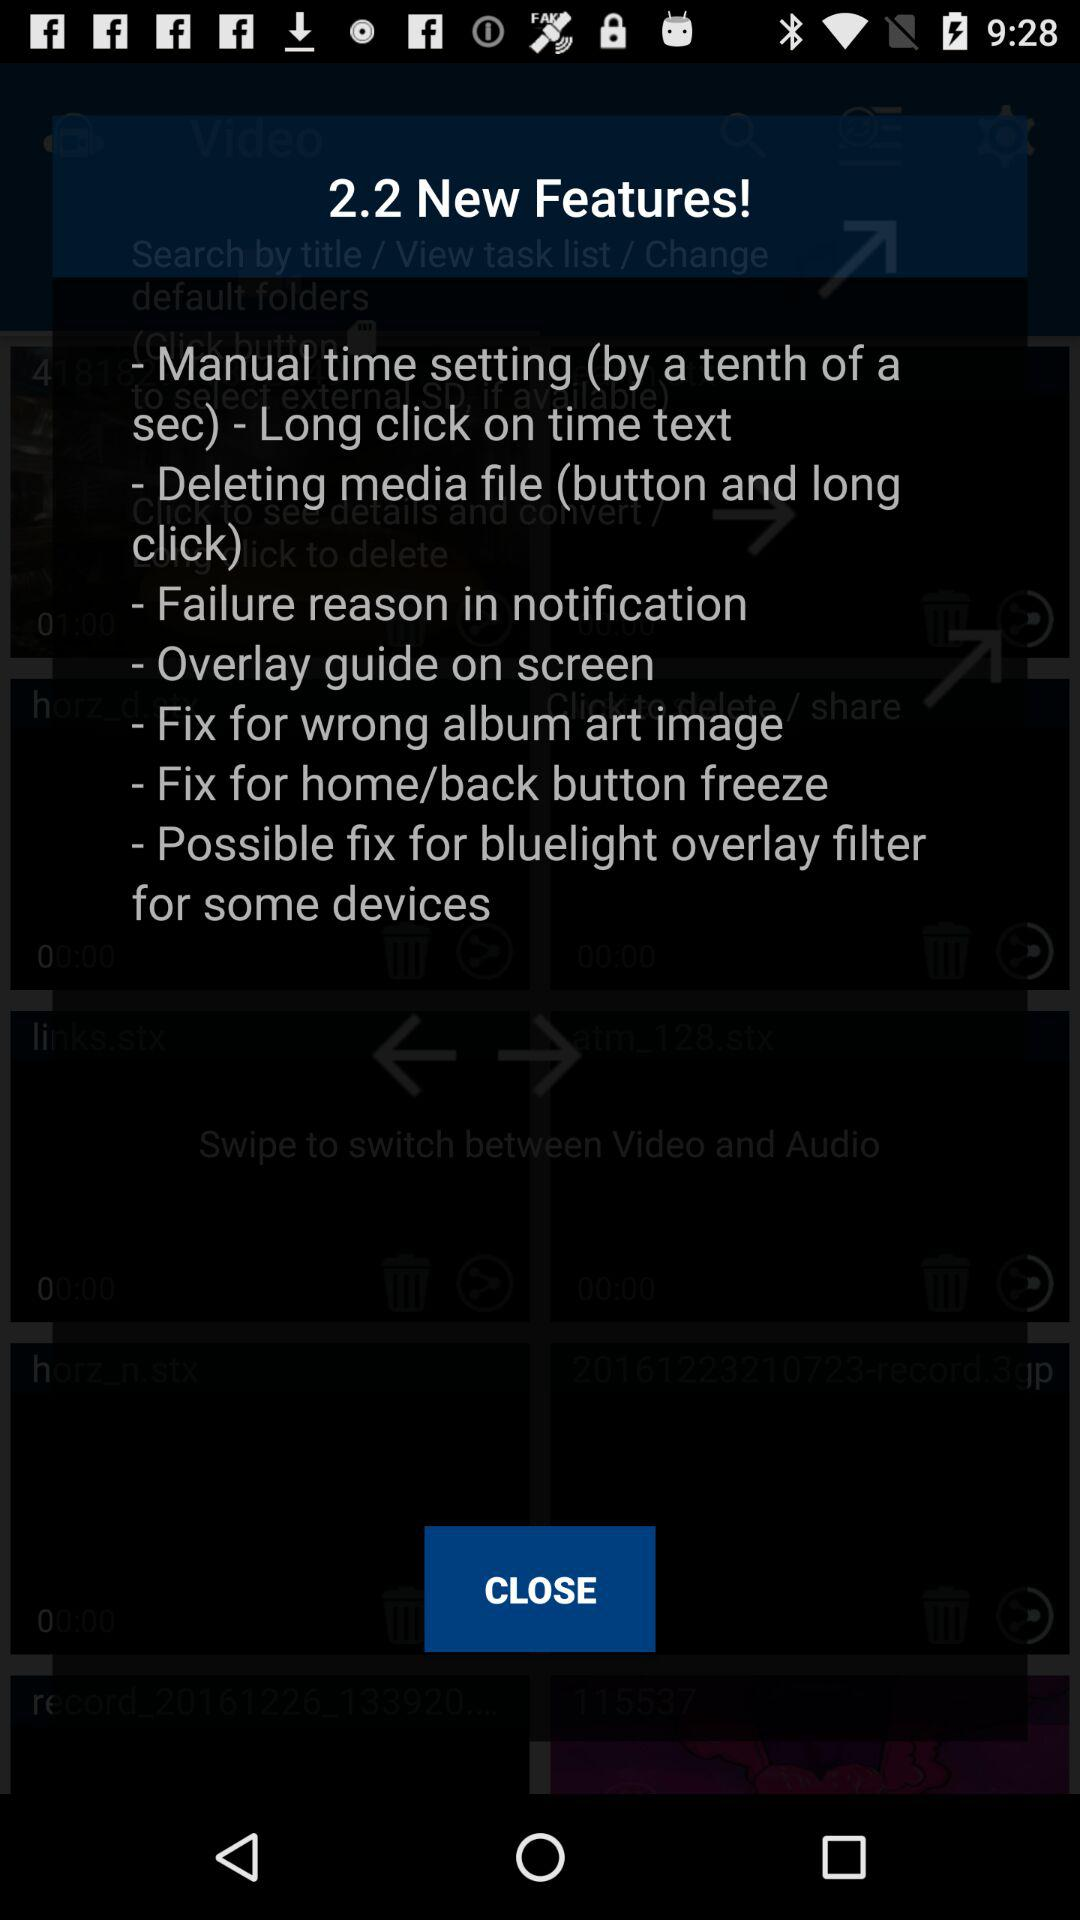What is the new features? The new features are "Manual time setting (by a tenth of a sec) - Long click on time text", "Deleting media file (button and long click)", "Failure reason in notification", " Overlay guide on screen", "Fix for wrong album art image", "Fix for home/back button freeze" and "Possible fix for bluelight overlay filter for some devices". 